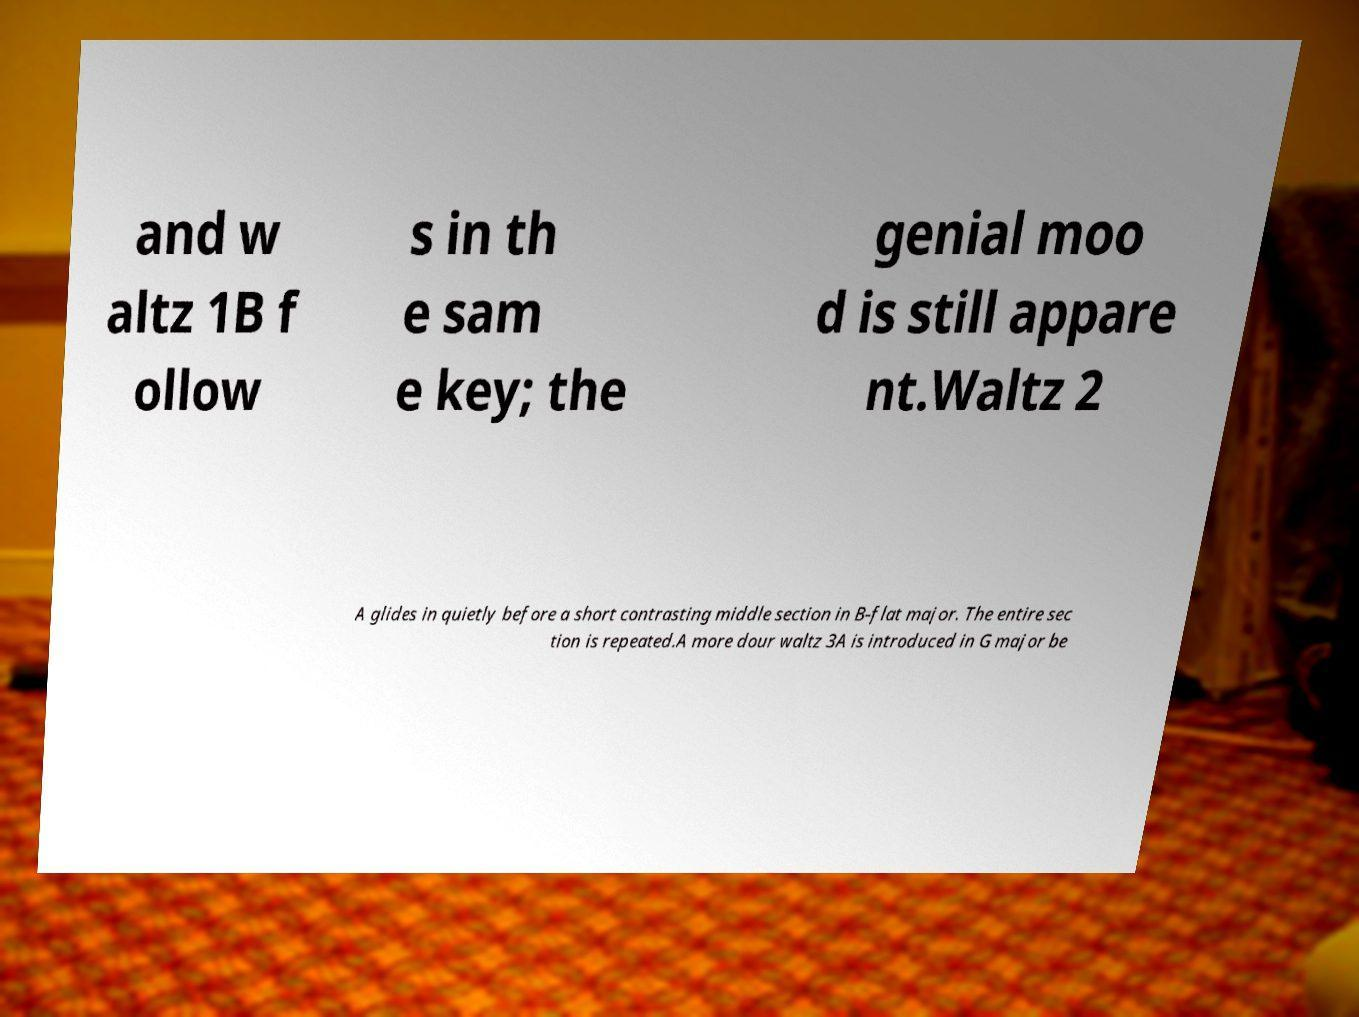Can you read and provide the text displayed in the image?This photo seems to have some interesting text. Can you extract and type it out for me? and w altz 1B f ollow s in th e sam e key; the genial moo d is still appare nt.Waltz 2 A glides in quietly before a short contrasting middle section in B-flat major. The entire sec tion is repeated.A more dour waltz 3A is introduced in G major be 